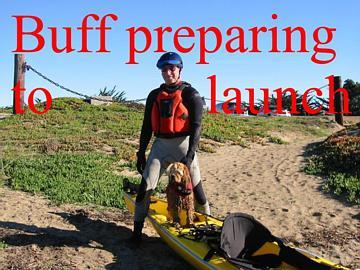Based on the given image information, briefly narrate a story involving the man and his dog. On a sunny day with a clear blue sky, a man and his loyal brown dog excitedly prepared to embark on a kayaking adventure. Dressed in a wet suit, orange life vest, helmet, and sunglasses, the man ensured his dog was seated safely in the yellow kayak. As they made their way down the sandy road, the bond between them grew stronger with each shared moment. Explain the significance of the life vest and helmet in this image context. The life vest and helmet signify that the man is taking proper safety precautions while engaging in water activities with his dog. List all the colors mentioned in the object caption and specify the count of each color. Black (4), orange (3), yellow (3), blue (2), grey (1), and brown (1). Describe the interaction between the man and his dog in the image. The man is preparing to launch his boat, while the dog is present in the kayak, showcasing a bonding experience between them during water activities. Identify three objects related to safety and describe their purpose. Life vest (provides buoyancy to keep the wearer afloat), helmet (protects the head from injury), and wet suit (protects the body and preserves warmth in cold water). What is the overarching theme of the image based on the objects and people present? The theme of the image is a man and his dog preparing for water activities, such as kayaking, while dressed in the appropriate safety gear. Describe the role of the sky in the visual context and sentiment of the image. The clear blue sky without any clouds adds to the overall sentiment of adventure and serenity, setting a perfect backdrop for water activities. Count the number of objects related to water activities present in the image and list them. There are 12 water-related objects: rope (4 instances), life vest (3 instances), helmet, kayak (2 instances), and wet suit (2 instances). Count the number of objects that are described as being either part of clothing or of the same category. There are 6 objects in this category: life vest (3 instances), wet suit pants, wet suit top, and helmet. Based on the objects and situation depicted in the image, describe the emotion or feeling portrayed in the scene. The image conveys a sense of adventure, excitement, and bonding as the man and his dog prepare to partake in water activities while fully geared for safety. 